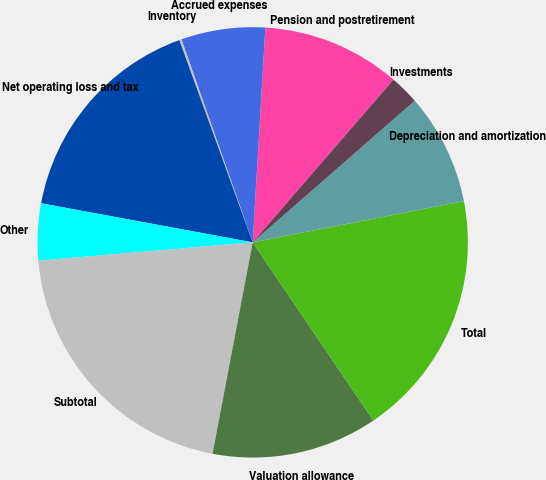Convert chart. <chart><loc_0><loc_0><loc_500><loc_500><pie_chart><fcel>Pension and postretirement<fcel>Accrued expenses<fcel>Inventory<fcel>Net operating loss and tax<fcel>Other<fcel>Subtotal<fcel>Valuation allowance<fcel>Total<fcel>Depreciation and amortization<fcel>Investments<nl><fcel>10.41%<fcel>6.31%<fcel>0.17%<fcel>16.55%<fcel>4.27%<fcel>20.65%<fcel>12.46%<fcel>18.6%<fcel>8.36%<fcel>2.22%<nl></chart> 